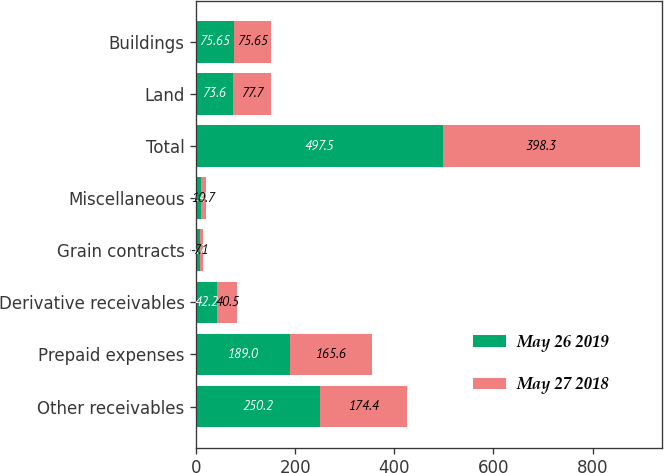Convert chart to OTSL. <chart><loc_0><loc_0><loc_500><loc_500><stacked_bar_chart><ecel><fcel>Other receivables<fcel>Prepaid expenses<fcel>Derivative receivables<fcel>Grain contracts<fcel>Miscellaneous<fcel>Total<fcel>Land<fcel>Buildings<nl><fcel>May 26 2019<fcel>250.2<fcel>189<fcel>42.2<fcel>6.7<fcel>9.4<fcel>497.5<fcel>73.6<fcel>75.65<nl><fcel>May 27 2018<fcel>174.4<fcel>165.6<fcel>40.5<fcel>7.1<fcel>10.7<fcel>398.3<fcel>77.7<fcel>75.65<nl></chart> 